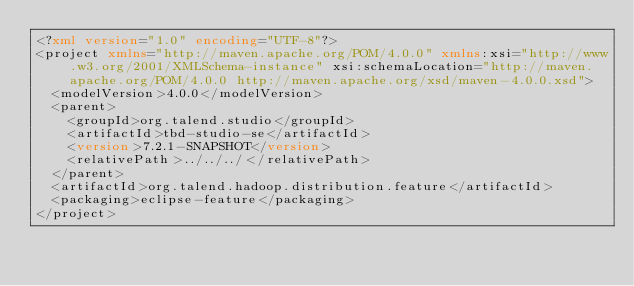Convert code to text. <code><loc_0><loc_0><loc_500><loc_500><_XML_><?xml version="1.0" encoding="UTF-8"?>
<project xmlns="http://maven.apache.org/POM/4.0.0" xmlns:xsi="http://www.w3.org/2001/XMLSchema-instance" xsi:schemaLocation="http://maven.apache.org/POM/4.0.0 http://maven.apache.org/xsd/maven-4.0.0.xsd">
  <modelVersion>4.0.0</modelVersion>
  <parent>
    <groupId>org.talend.studio</groupId>
    <artifactId>tbd-studio-se</artifactId>
    <version>7.2.1-SNAPSHOT</version>
    <relativePath>../../../</relativePath>
  </parent>
  <artifactId>org.talend.hadoop.distribution.feature</artifactId>
  <packaging>eclipse-feature</packaging>
</project>
</code> 